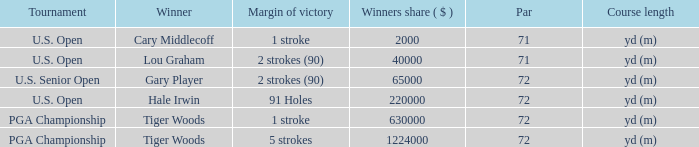During 1999, how many tourneys took place? 1.0. 